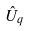<formula> <loc_0><loc_0><loc_500><loc_500>\hat { U } _ { q }</formula> 